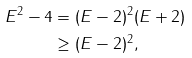<formula> <loc_0><loc_0><loc_500><loc_500>E ^ { 2 } - 4 & = ( E - 2 ) ^ { 2 } ( E + 2 ) \\ & \geq ( E - 2 ) ^ { 2 } ,</formula> 